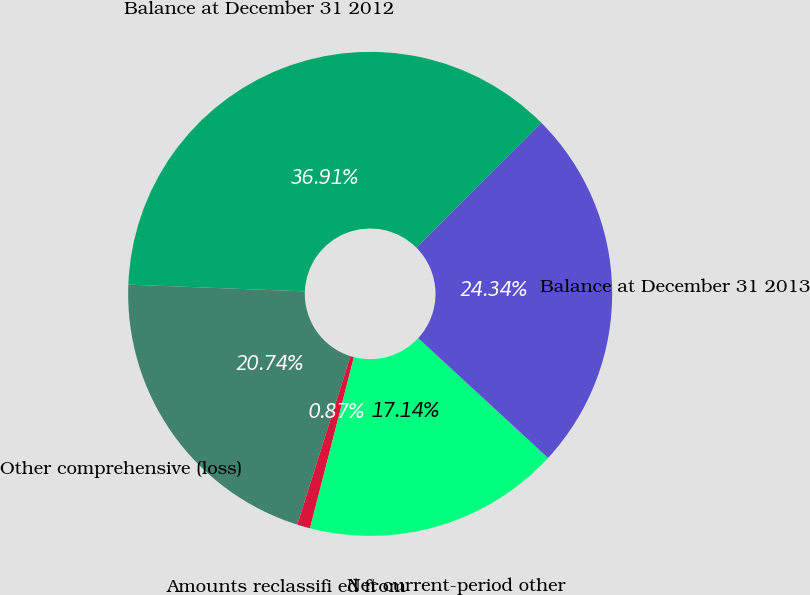Convert chart to OTSL. <chart><loc_0><loc_0><loc_500><loc_500><pie_chart><fcel>Balance at December 31 2012<fcel>Other comprehensive (loss)<fcel>Amounts reclassifi ed from<fcel>Net current-period other<fcel>Balance at December 31 2013<nl><fcel>36.91%<fcel>20.74%<fcel>0.87%<fcel>17.14%<fcel>24.34%<nl></chart> 